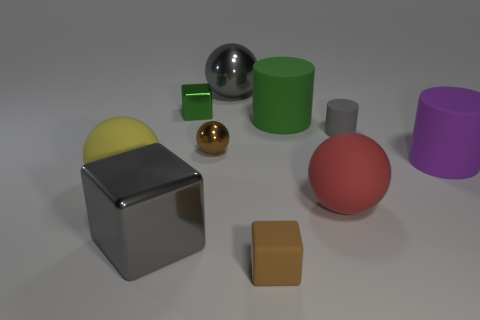What is the material of the green thing that is the same size as the brown block?
Provide a short and direct response. Metal. Is the large ball behind the brown metallic object made of the same material as the small block right of the small sphere?
Your answer should be very brief. No. The yellow object that is the same size as the gray ball is what shape?
Your answer should be compact. Sphere. How many other things are the same color as the big metallic sphere?
Your response must be concise. 2. The big rubber ball left of the tiny brown matte thing is what color?
Offer a terse response. Yellow. What number of other objects are the same material as the gray cylinder?
Make the answer very short. 5. Are there more objects in front of the large purple matte cylinder than rubber objects behind the gray shiny cube?
Your answer should be compact. No. How many tiny brown balls are on the right side of the brown metallic ball?
Make the answer very short. 0. Does the red object have the same material as the tiny block that is behind the big red rubber thing?
Your answer should be very brief. No. Is there anything else that is the same shape as the red thing?
Give a very brief answer. Yes. 